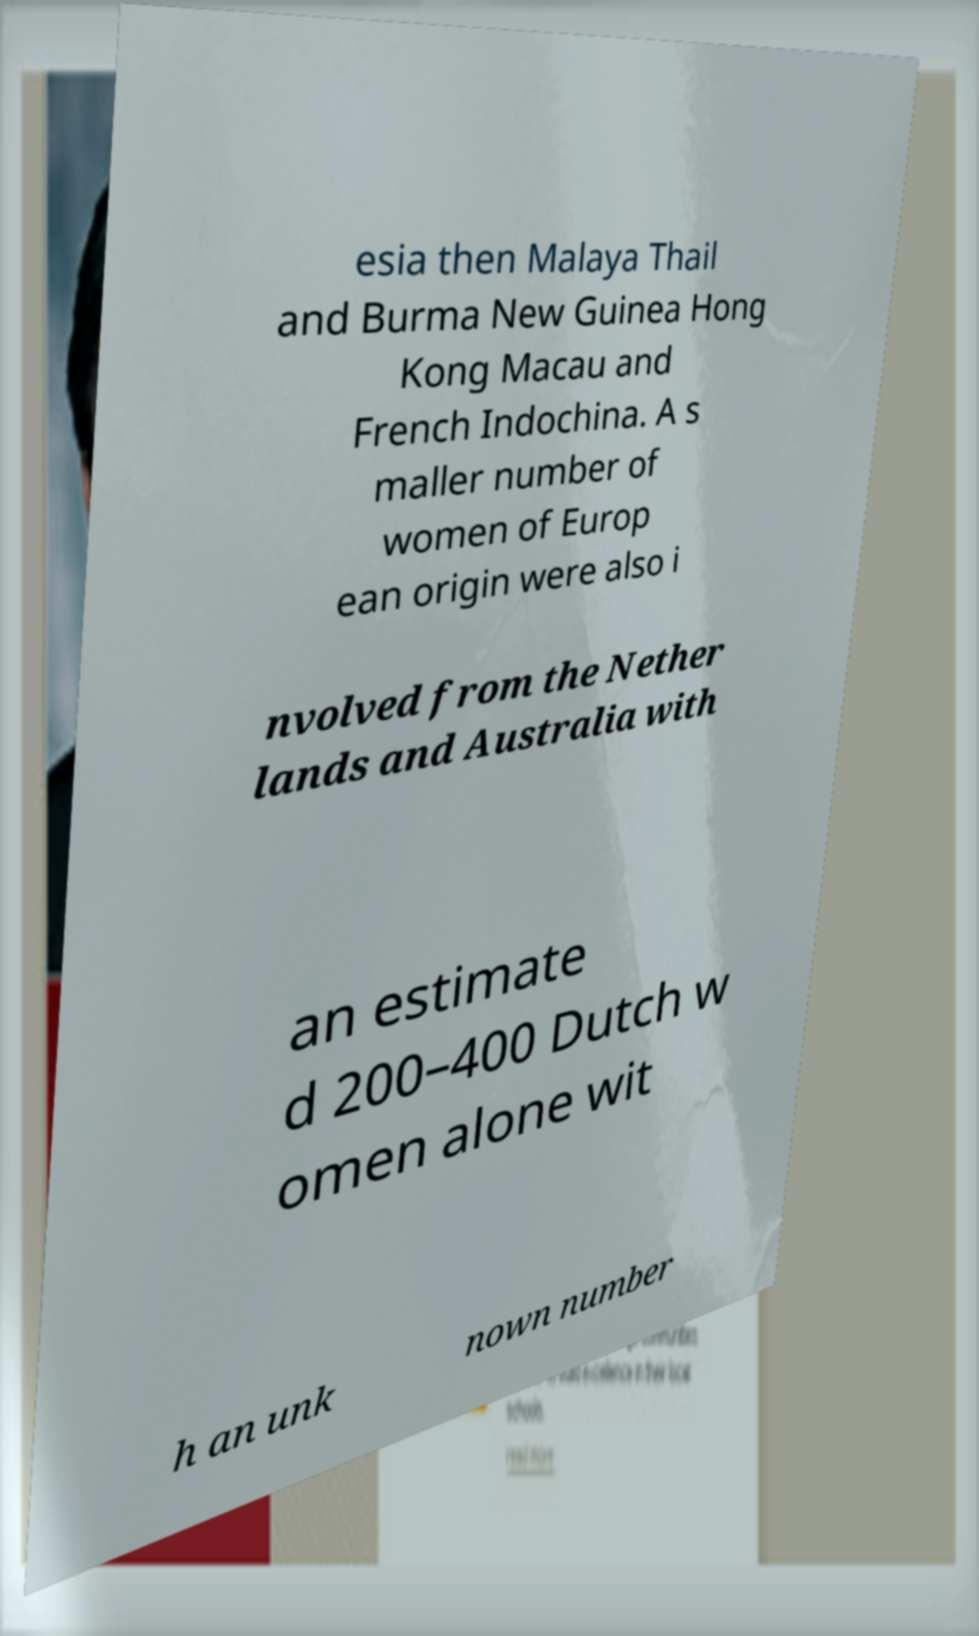There's text embedded in this image that I need extracted. Can you transcribe it verbatim? esia then Malaya Thail and Burma New Guinea Hong Kong Macau and French Indochina. A s maller number of women of Europ ean origin were also i nvolved from the Nether lands and Australia with an estimate d 200–400 Dutch w omen alone wit h an unk nown number 